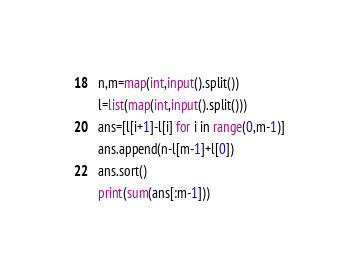Convert code to text. <code><loc_0><loc_0><loc_500><loc_500><_Python_>n,m=map(int,input().split())
l=list(map(int,input().split()))
ans=[l[i+1]-l[i] for i in range(0,m-1)]
ans.append(n-l[m-1]+l[0])
ans.sort()
print(sum(ans[:m-1]))</code> 